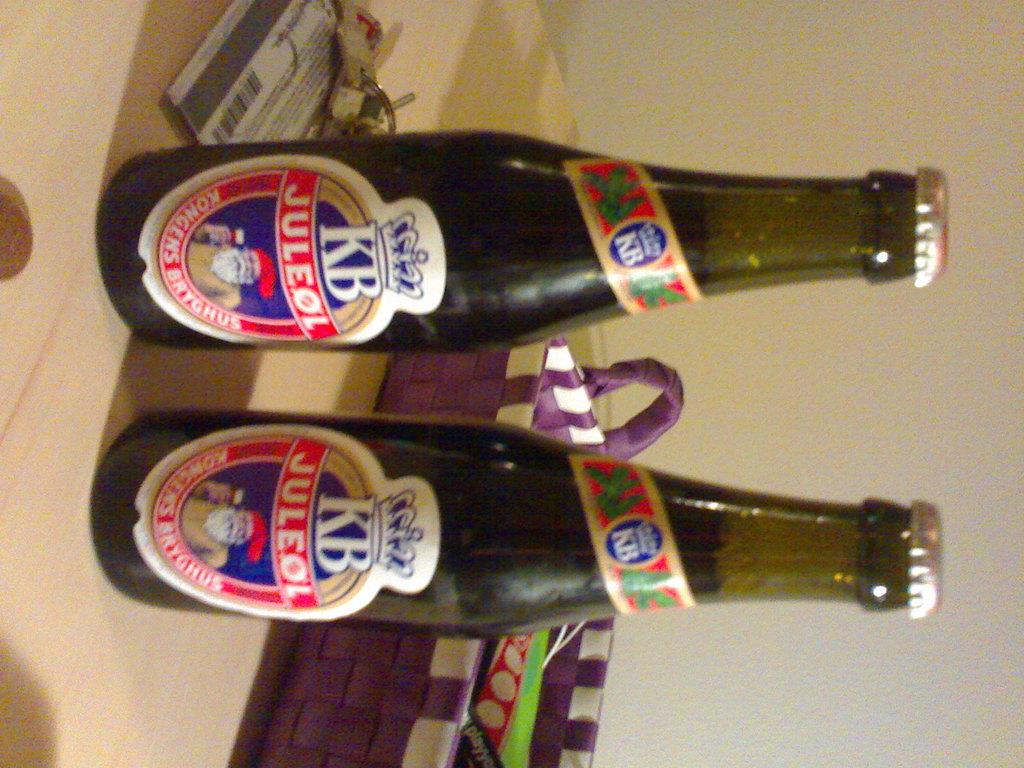What is the brand of the beer?
Offer a very short reply. Kb. 